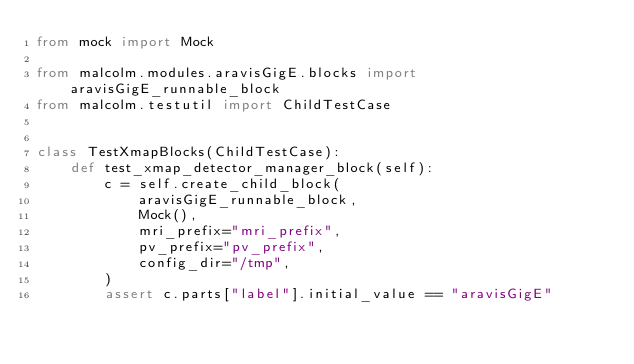Convert code to text. <code><loc_0><loc_0><loc_500><loc_500><_Python_>from mock import Mock

from malcolm.modules.aravisGigE.blocks import aravisGigE_runnable_block
from malcolm.testutil import ChildTestCase


class TestXmapBlocks(ChildTestCase):
    def test_xmap_detector_manager_block(self):
        c = self.create_child_block(
            aravisGigE_runnable_block,
            Mock(),
            mri_prefix="mri_prefix",
            pv_prefix="pv_prefix",
            config_dir="/tmp",
        )
        assert c.parts["label"].initial_value == "aravisGigE"
</code> 